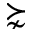<formula> <loc_0><loc_0><loc_500><loc_500>\succnsim</formula> 